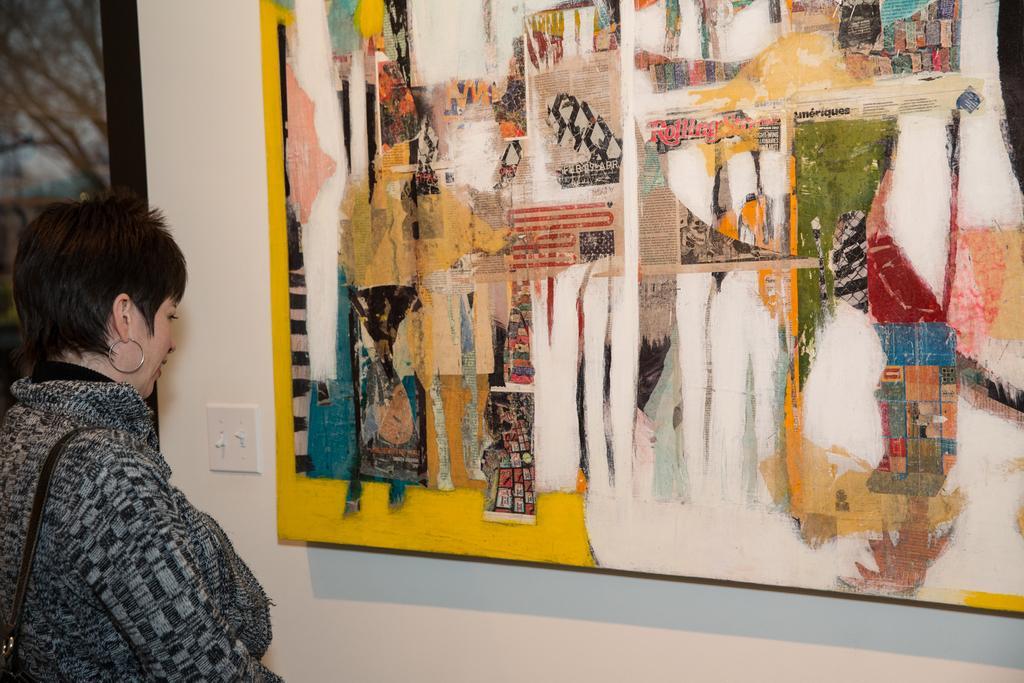Can you describe this image briefly? There is a woman standing and we can see strap,in front of her we can see painting boards and switch board on the wall. 